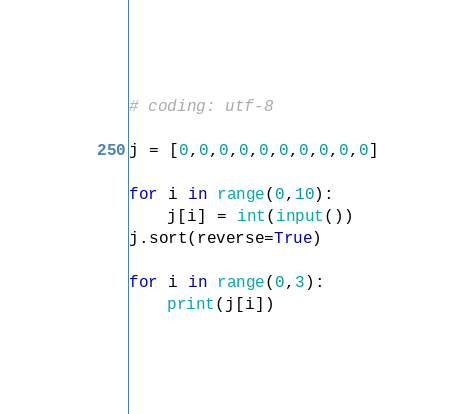<code> <loc_0><loc_0><loc_500><loc_500><_Python_># coding: utf-8

j = [0,0,0,0,0,0,0,0,0,0]

for i in range(0,10):
    j[i] = int(input())
j.sort(reverse=True)

for i in range(0,3):
    print(j[i])

</code> 